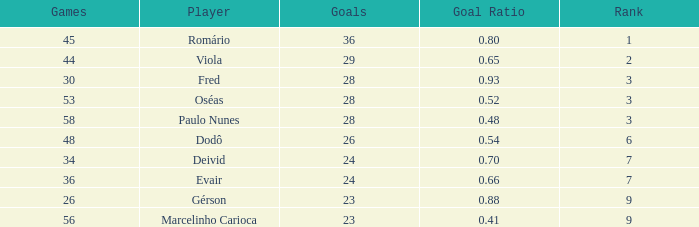What is the largest value for goals in rank over 3 with goal ration of 0.54? 26.0. 